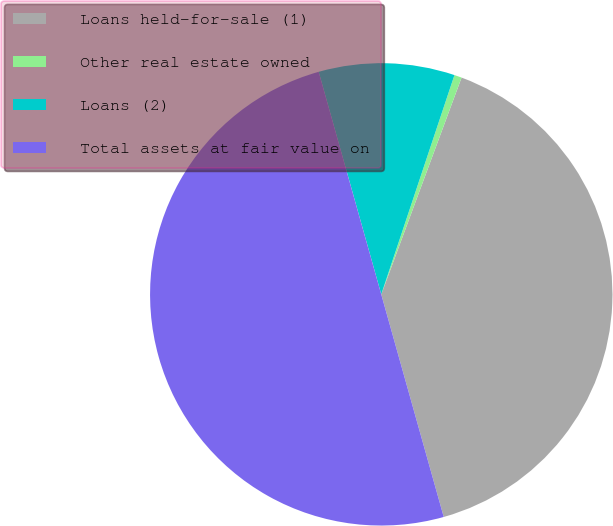Convert chart to OTSL. <chart><loc_0><loc_0><loc_500><loc_500><pie_chart><fcel>Loans held-for-sale (1)<fcel>Other real estate owned<fcel>Loans (2)<fcel>Total assets at fair value on<nl><fcel>40.0%<fcel>0.52%<fcel>9.49%<fcel>50.0%<nl></chart> 